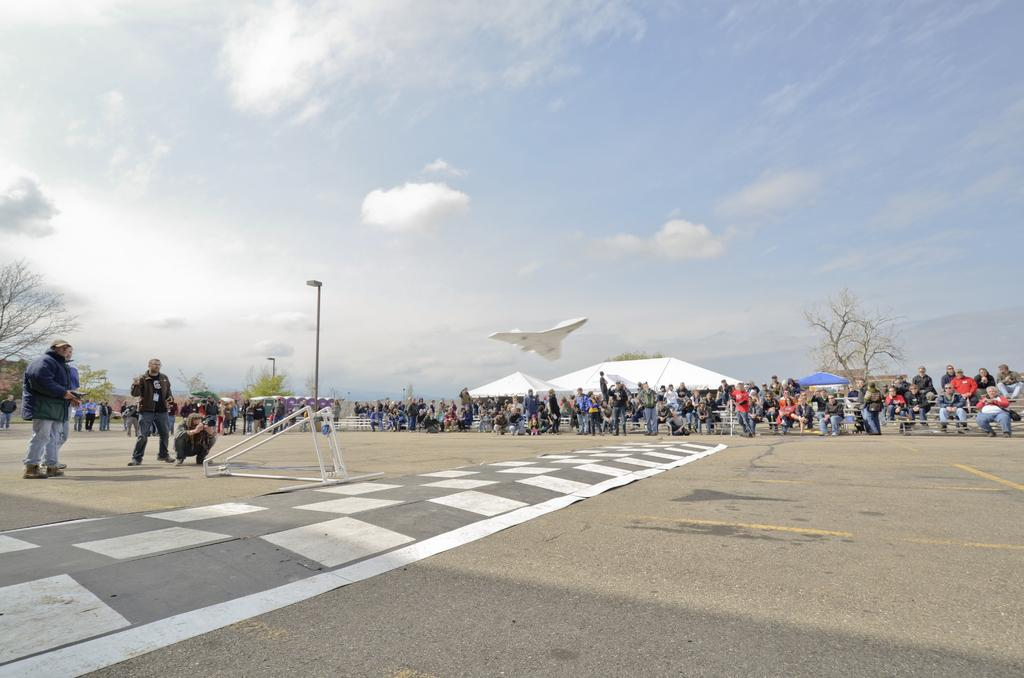What type of structure is present in the image? There is a metal frame in the image. What is the main subject of the image? There is an aircraft in the image. What type of buildings can be seen in the image? There are sheds in the image. What type of vegetation is present in the image? There are trees in the image. What type of lighting is present in the image? There is a street light in the image. What is visible in the background of the image? The sky is visible in the image. What is happening on the road in the image? There are people standing on the road in the image. Can you tell me how many islands are visible in the image? There are no islands present in the image. What type of stretch is being used by the people standing on the road in the image? There is no stretch being used by the people standing on the road in the image. 